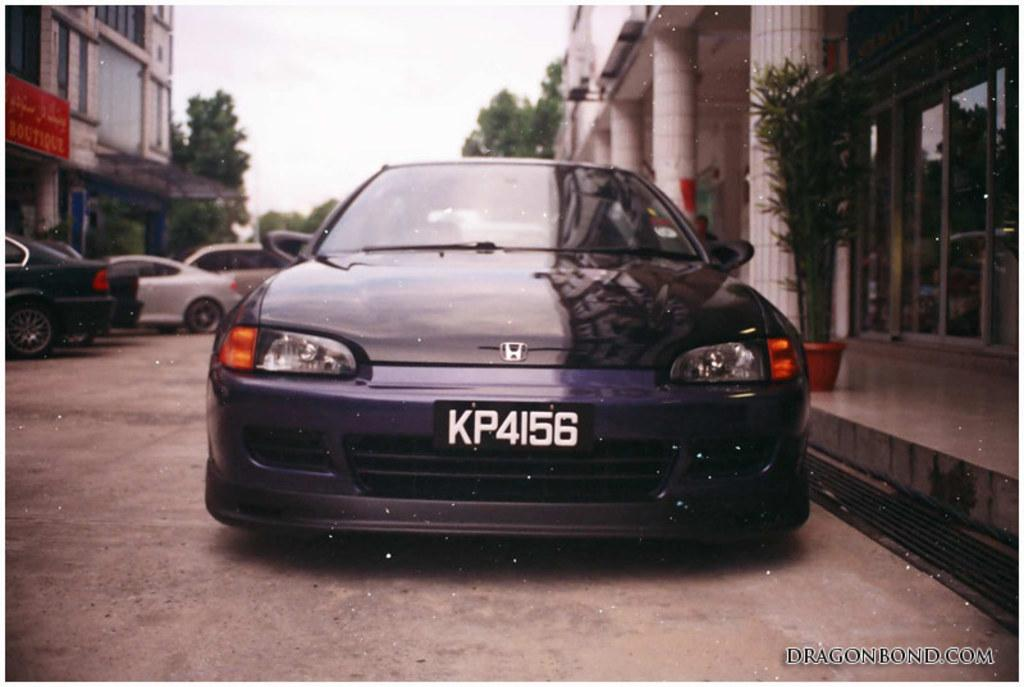What can be seen on the road in the image? There are cars on the road in the image. What surrounds the road in the image? There are buildings on either side of the road in the image. What is in front of the buildings in the image? There are trees in front of the buildings in the image. What is visible above the scene in the image? The sky is visible above the scene in the image. How long does it take for the partner to finish the board in the image? There is no partner or board present in the image. How many minutes does it take for the cars to pass by in the image? The image does not provide information about the duration of time it takes for the cars to pass by. 